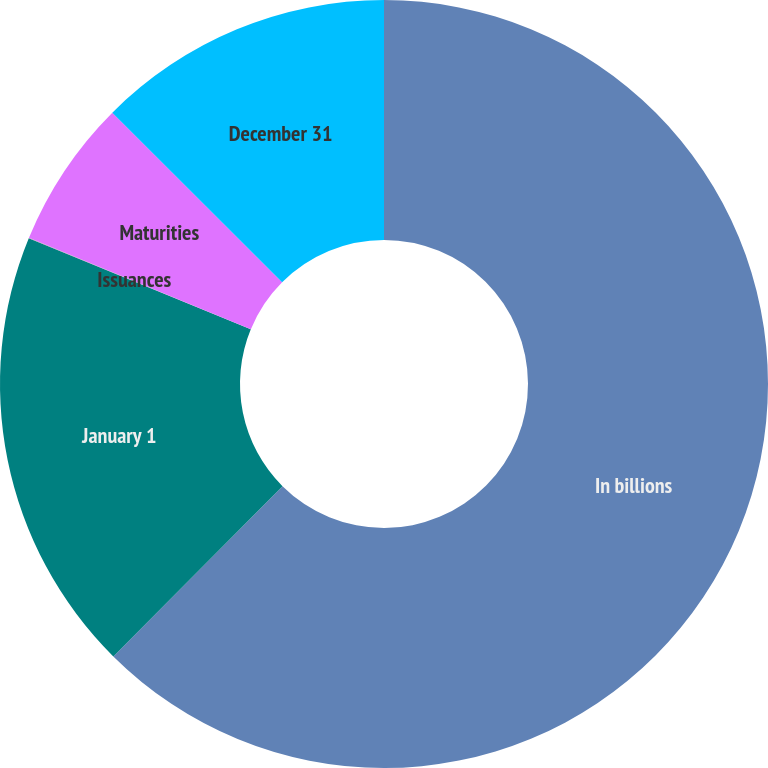Convert chart to OTSL. <chart><loc_0><loc_0><loc_500><loc_500><pie_chart><fcel>In billions<fcel>January 1<fcel>Issuances<fcel>Maturities<fcel>December 31<nl><fcel>62.45%<fcel>18.75%<fcel>0.02%<fcel>6.27%<fcel>12.51%<nl></chart> 